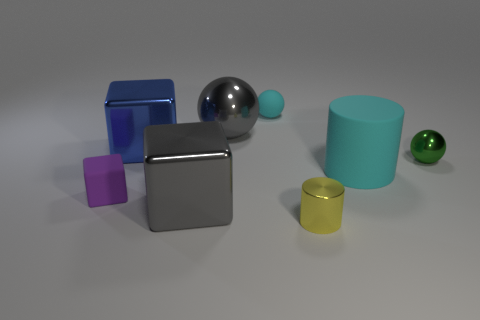There is a large cube to the left of the big object in front of the rubber cylinder; what color is it?
Your response must be concise. Blue. What material is the large thing that is the same color as the small rubber ball?
Your answer should be very brief. Rubber. There is a small rubber object to the right of the large gray metal ball; what is its color?
Offer a terse response. Cyan. There is a cyan rubber object that is in front of the cyan rubber ball; is it the same size as the gray metallic block?
Offer a terse response. Yes. There is another matte object that is the same color as the large rubber thing; what is its size?
Provide a short and direct response. Small. Are there any purple rubber cubes that have the same size as the rubber ball?
Your response must be concise. Yes. Is the color of the rubber thing that is to the left of the blue object the same as the shiny cylinder that is right of the tiny block?
Ensure brevity in your answer.  No. Are there any metal cubes of the same color as the big ball?
Your answer should be very brief. Yes. How many other things are there of the same shape as the tiny cyan thing?
Provide a succinct answer. 2. There is a small matte thing left of the big gray block; what shape is it?
Offer a terse response. Cube. 